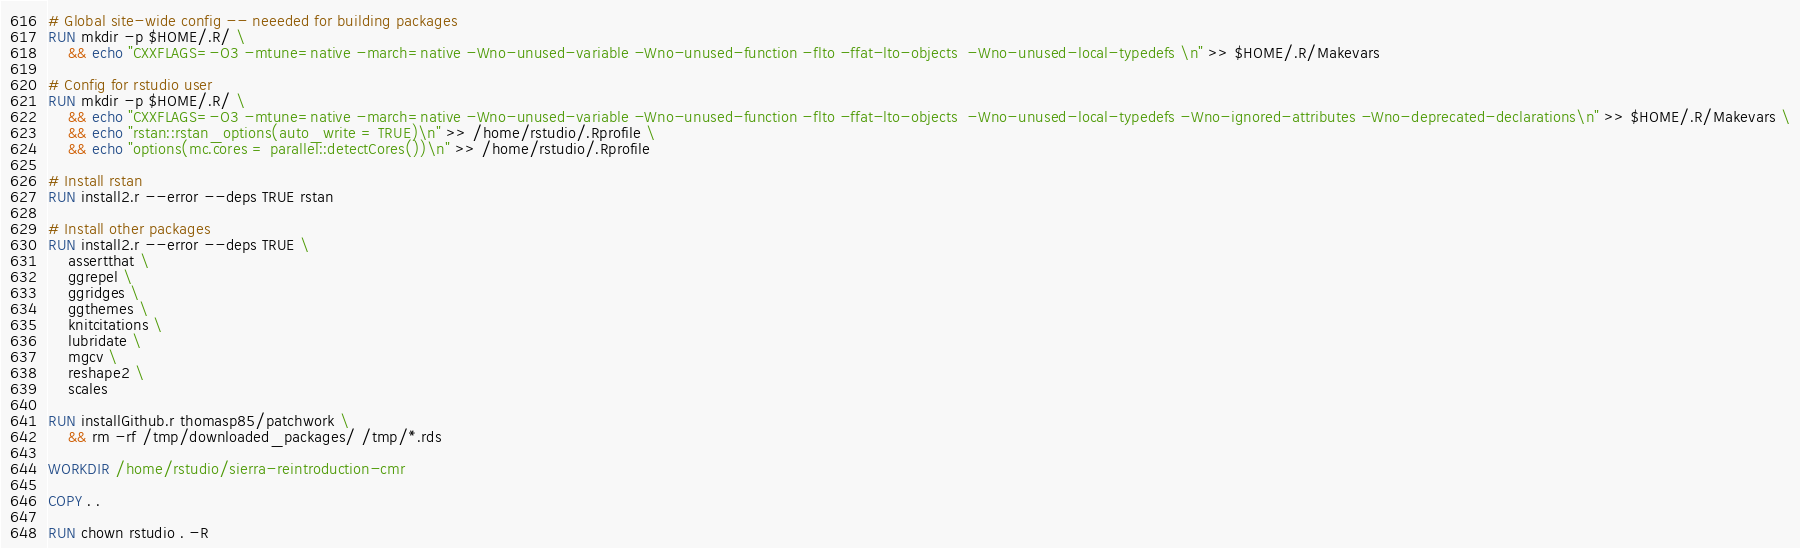Convert code to text. <code><loc_0><loc_0><loc_500><loc_500><_Dockerfile_>
# Global site-wide config -- neeeded for building packages
RUN mkdir -p $HOME/.R/ \
    && echo "CXXFLAGS=-O3 -mtune=native -march=native -Wno-unused-variable -Wno-unused-function -flto -ffat-lto-objects  -Wno-unused-local-typedefs \n" >> $HOME/.R/Makevars

# Config for rstudio user
RUN mkdir -p $HOME/.R/ \
    && echo "CXXFLAGS=-O3 -mtune=native -march=native -Wno-unused-variable -Wno-unused-function -flto -ffat-lto-objects  -Wno-unused-local-typedefs -Wno-ignored-attributes -Wno-deprecated-declarations\n" >> $HOME/.R/Makevars \
    && echo "rstan::rstan_options(auto_write = TRUE)\n" >> /home/rstudio/.Rprofile \
    && echo "options(mc.cores = parallel::detectCores())\n" >> /home/rstudio/.Rprofile

# Install rstan
RUN install2.r --error --deps TRUE rstan

# Install other packages
RUN install2.r --error --deps TRUE \
    assertthat \
    ggrepel \
    ggridges \
    ggthemes \
    knitcitations \
    lubridate \
    mgcv \
    reshape2 \
    scales

RUN installGithub.r thomasp85/patchwork \
    && rm -rf /tmp/downloaded_packages/ /tmp/*.rds

WORKDIR /home/rstudio/sierra-reintroduction-cmr

COPY . .

RUN chown rstudio . -R

</code> 